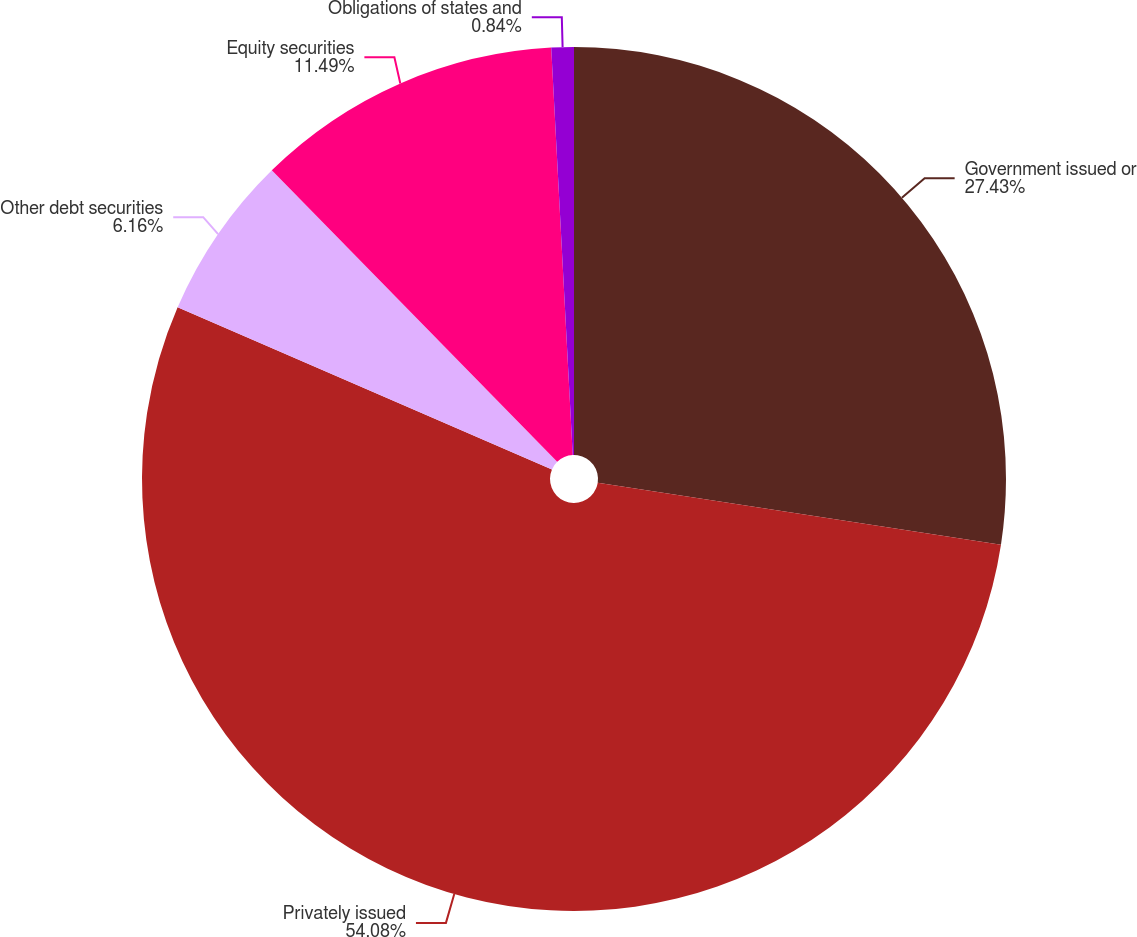Convert chart to OTSL. <chart><loc_0><loc_0><loc_500><loc_500><pie_chart><fcel>Government issued or<fcel>Privately issued<fcel>Other debt securities<fcel>Equity securities<fcel>Obligations of states and<nl><fcel>27.43%<fcel>54.08%<fcel>6.16%<fcel>11.49%<fcel>0.84%<nl></chart> 